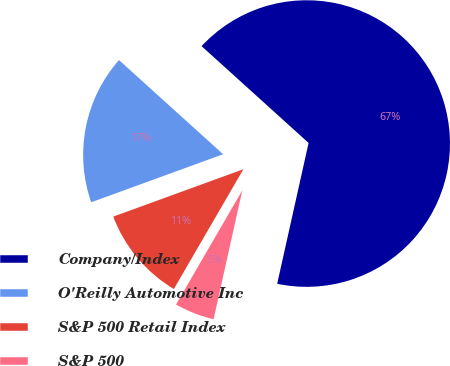Convert chart to OTSL. <chart><loc_0><loc_0><loc_500><loc_500><pie_chart><fcel>Company/Index<fcel>O'Reilly Automotive Inc<fcel>S&P 500 Retail Index<fcel>S&P 500<nl><fcel>66.79%<fcel>17.26%<fcel>11.07%<fcel>4.88%<nl></chart> 